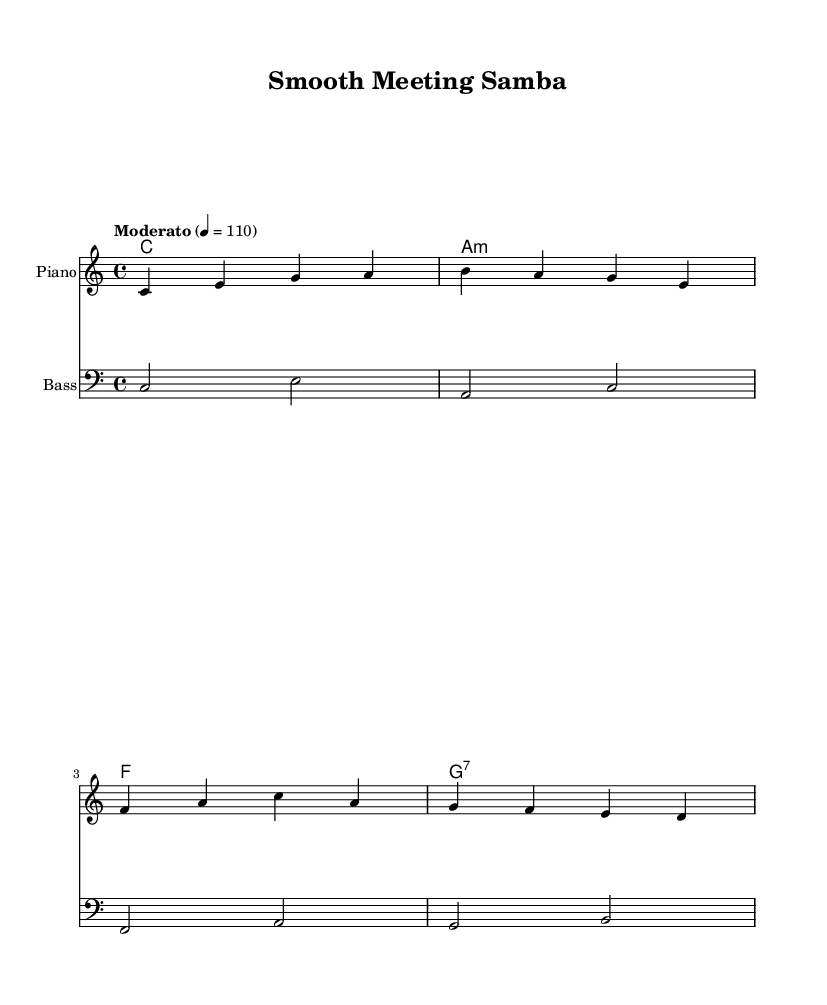What is the key signature of this music? The key signature is C major, which has no sharps or flats.
Answer: C major What is the time signature of this music? The time signature is indicated by the notation at the beginning of the score, which is 4/4, meaning there are four beats per measure.
Answer: 4/4 What is the tempo marking of this piece? The tempo marking is shown in the score, indicating a moderate speed of 110 beats per minute, noted as "Moderato."
Answer: Moderato How many measures are there in the piano part? To determine the number of measures, count the bars in the piano staff, which has four measures.
Answer: Four What chords are used in the first section? The chords are presented in the chord names staff; the first section has C major, A minor, F major, and G7.
Answer: C, A minor, F, G7 Why is the music considered Latin jazz? The use of syncopated rhythms and a combination of jazz harmonies with Latin music styles characterizes this music as Latin jazz.
Answer: Syncopated rhythms and Latin harmonies Which instrument has the bass clef? The bass staff is explicitly notated with a bass clef symbol, indicating that the bass part is written for the lower range instruments.
Answer: Bass 